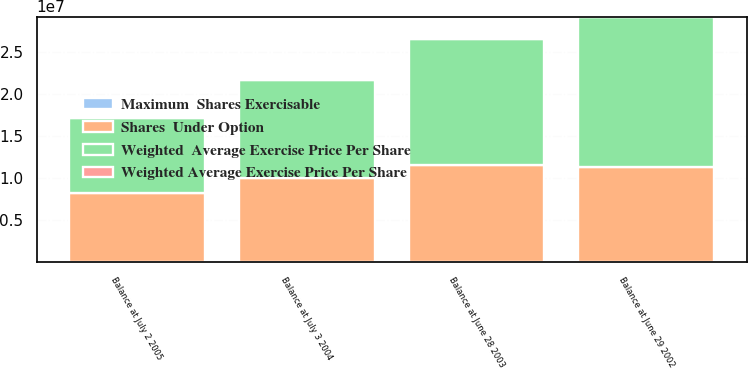Convert chart. <chart><loc_0><loc_0><loc_500><loc_500><stacked_bar_chart><ecel><fcel>Balance at June 29 2002<fcel>Balance at June 28 2003<fcel>Balance at July 3 2004<fcel>Balance at July 2 2005<nl><fcel>Shares  Under Option<fcel>1.12515e+07<fcel>1.15144e+07<fcel>1.00206e+07<fcel>8.25621e+06<nl><fcel>Weighted Average Exercise Price Per Share<fcel>11.38<fcel>13.01<fcel>14.5<fcel>15.29<nl><fcel>Weighted  Average Exercise Price Per Share<fcel>1.79393e+07<fcel>1.50288e+07<fcel>1.15746e+07<fcel>8.87143e+06<nl><fcel>Maximum  Shares Exercisable<fcel>13.78<fcel>14.12<fcel>14.68<fcel>15.2<nl></chart> 